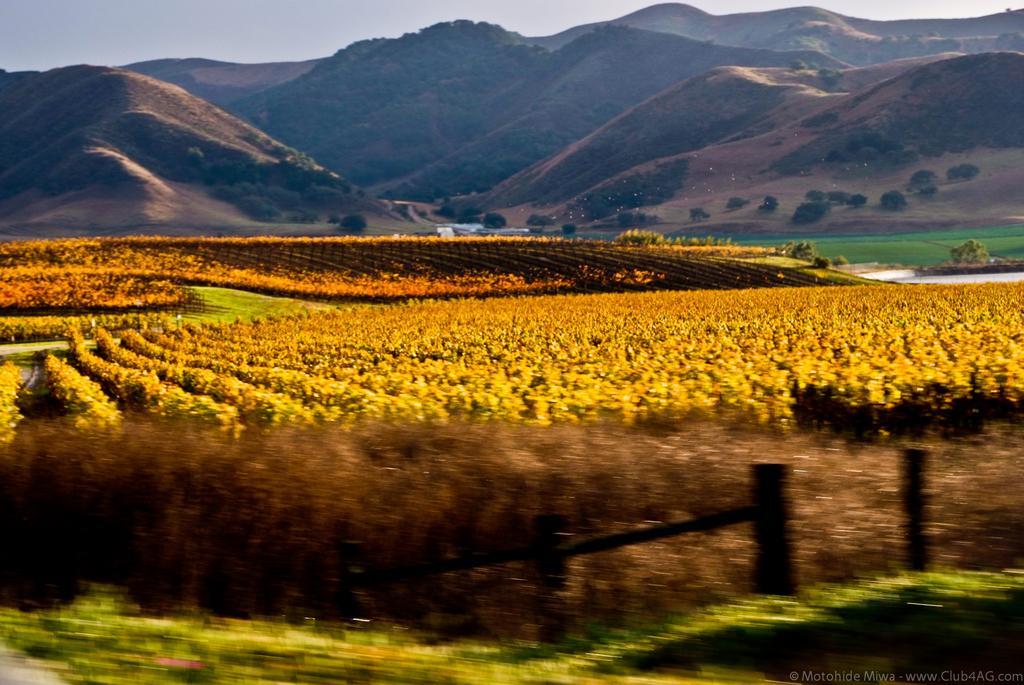Please provide a concise description of this image. In this image I can see number of yellow colour plants, mountains, trees and I can see grass. 